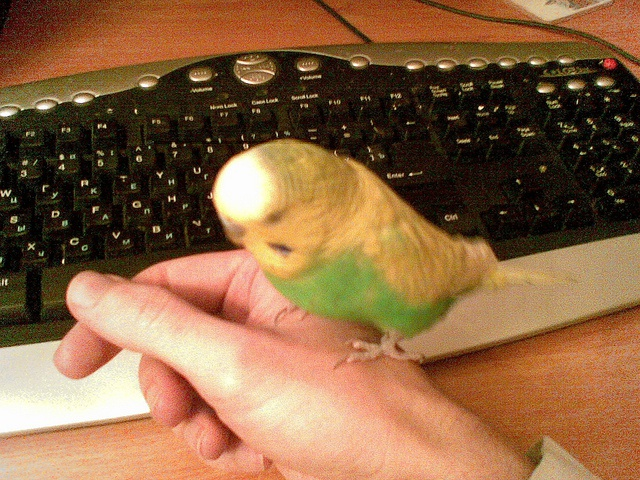Describe the objects in this image and their specific colors. I can see keyboard in black, tan, olive, and ivory tones, people in black, salmon, tan, and beige tones, and bird in black, orange, and olive tones in this image. 